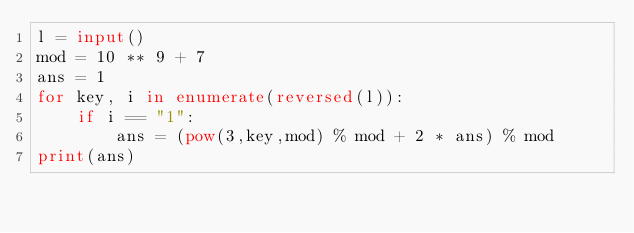<code> <loc_0><loc_0><loc_500><loc_500><_Python_>l = input()
mod = 10 ** 9 + 7
ans = 1
for key, i in enumerate(reversed(l)):
    if i == "1":
        ans = (pow(3,key,mod) % mod + 2 * ans) % mod
print(ans)
</code> 